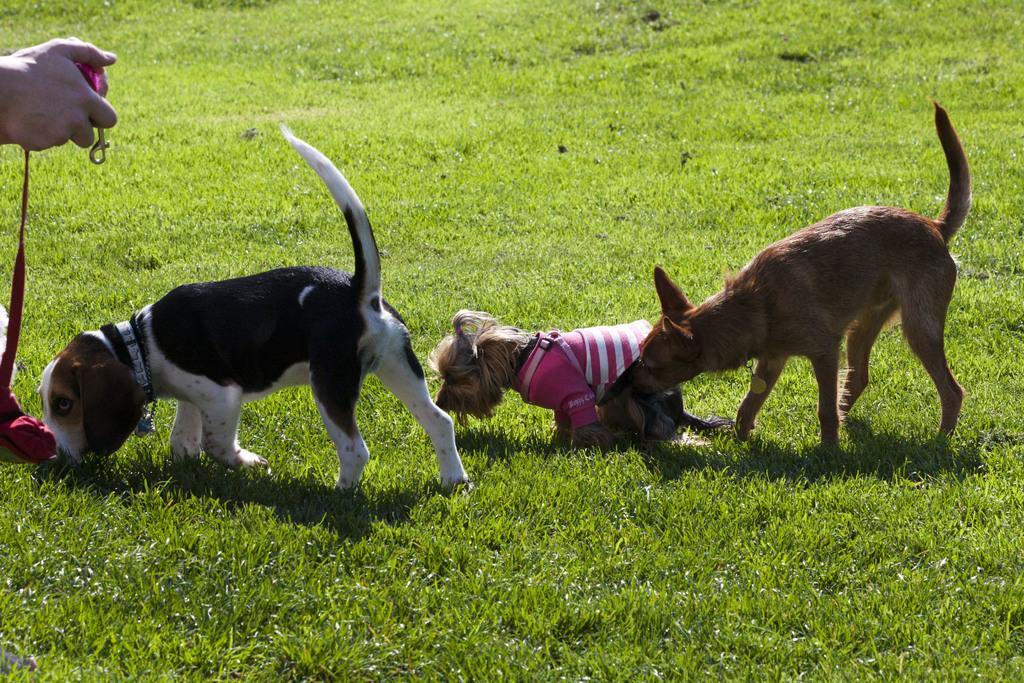Can you describe this image briefly? In this image we can see two dogs. We can also see a dog wearing the shirt. In the background we can see the grass. On the left there is some person holding the belt. 